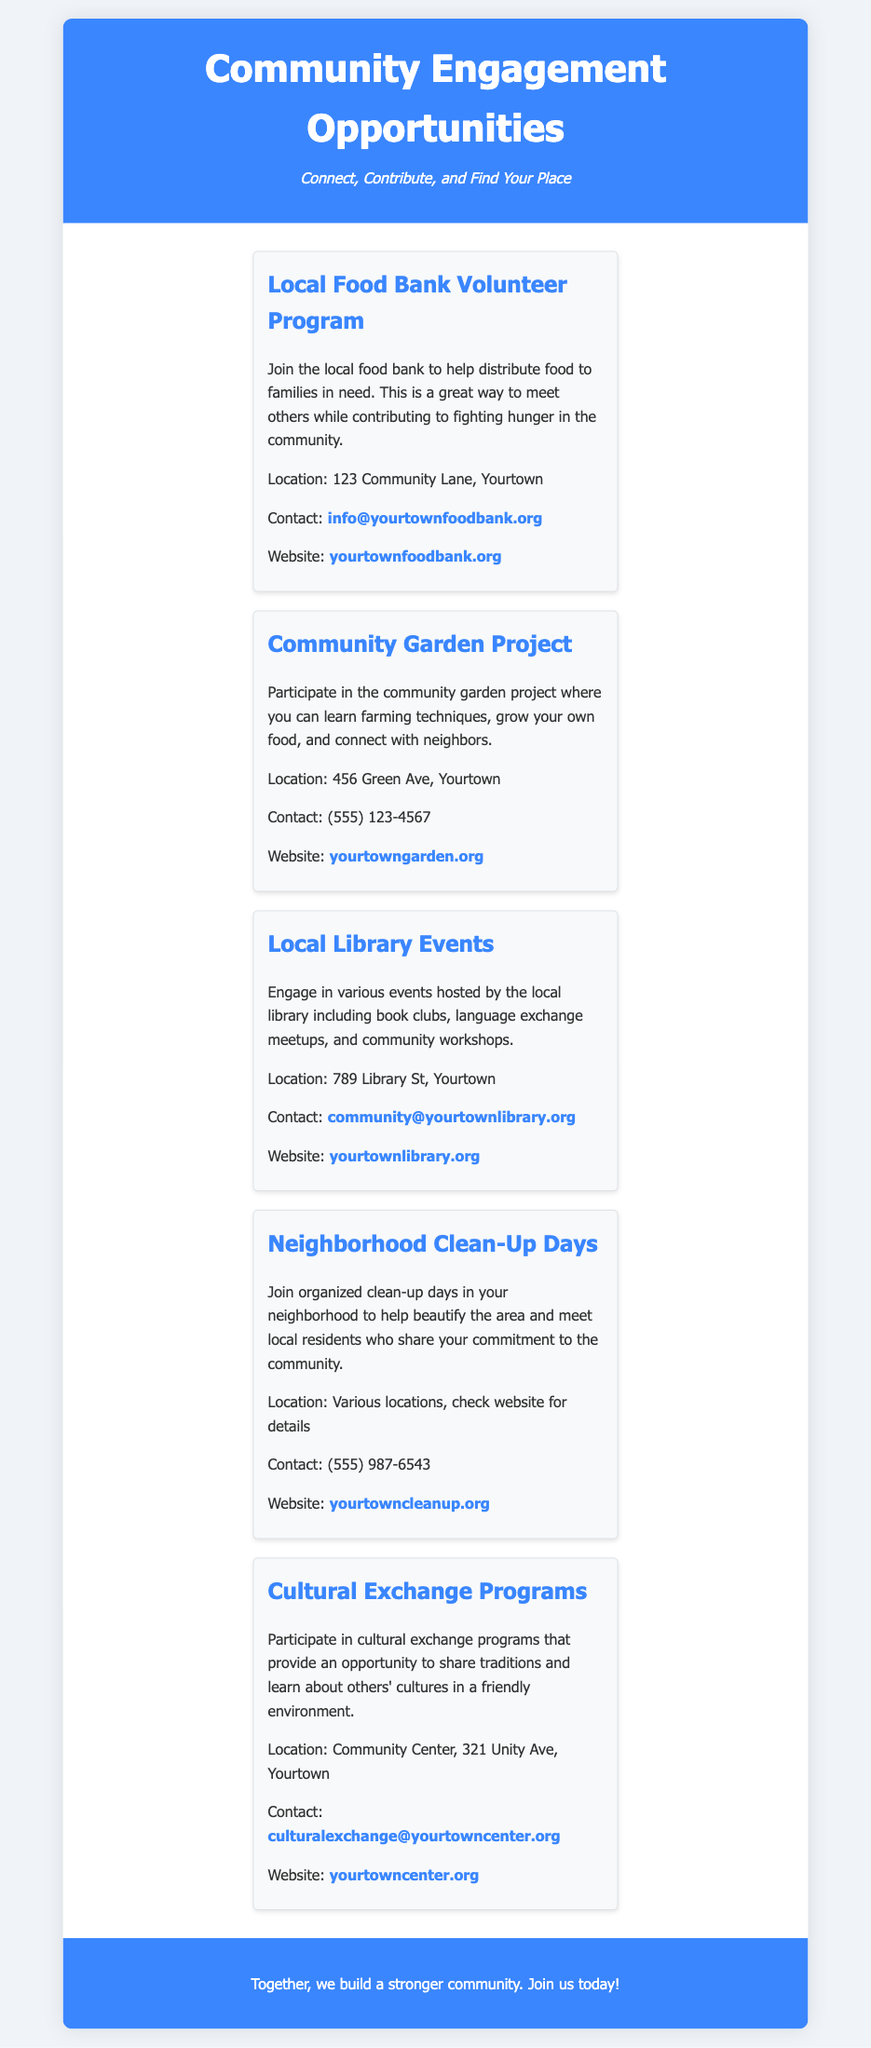what is the title of the document? The title appears at the top of the rendered document and is "Community Engagement Opportunities".
Answer: Community Engagement Opportunities how many local organizations are listed? The document lists five local organizations under community engagement opportunities.
Answer: 5 what is the contact email for the local food bank? The email for the local food bank can be found in the details section for the local food bank volunteer program.
Answer: info@yourtownfoodbank.org where is the Community Garden Project located? The location for the Community Garden Project is specified in the menu item for that organization.
Answer: 456 Green Ave, Yourtown what type of events does the local library host? The document mentions various events including book clubs and language exchange meetups.
Answer: book clubs and language exchange meetups which program is focused on sharing traditions? The Cultural Exchange Programs menu item describes an opportunity to share traditions.
Answer: Cultural Exchange Programs what can you learn at the Community Garden Project? The description for the Community Garden Project states that you can learn farming techniques.
Answer: farming techniques what is the phone contact for Neighborhood Clean-Up Days? The contact number for the Neighborhood Clean-Up Days is provided in the respective menu item.
Answer: (555) 987-6543 